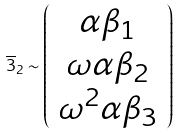<formula> <loc_0><loc_0><loc_500><loc_500>\overline { 3 } _ { 2 } \sim \left ( \begin{array} { c } \alpha \beta _ { 1 } \\ \omega \alpha \beta _ { 2 } \\ \omega ^ { 2 } \alpha \beta _ { 3 } \end{array} \right )</formula> 